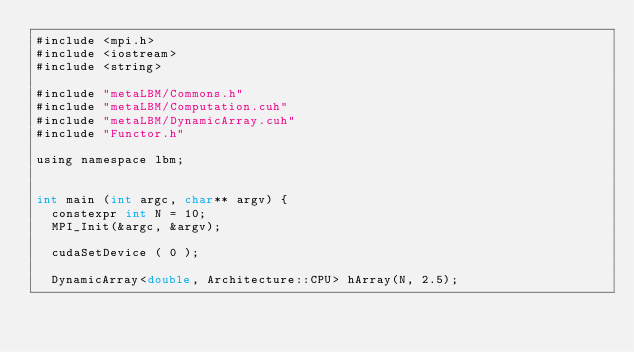<code> <loc_0><loc_0><loc_500><loc_500><_Cuda_>#include <mpi.h>
#include <iostream>
#include <string>

#include "metaLBM/Commons.h"
#include "metaLBM/Computation.cuh"
#include "metaLBM/DynamicArray.cuh"
#include "Functor.h"

using namespace lbm;


int main (int argc, char** argv) {
  constexpr int N = 10;
  MPI_Init(&argc, &argv);

  cudaSetDevice ( 0 );

  DynamicArray<double, Architecture::CPU> hArray(N, 2.5);

</code> 